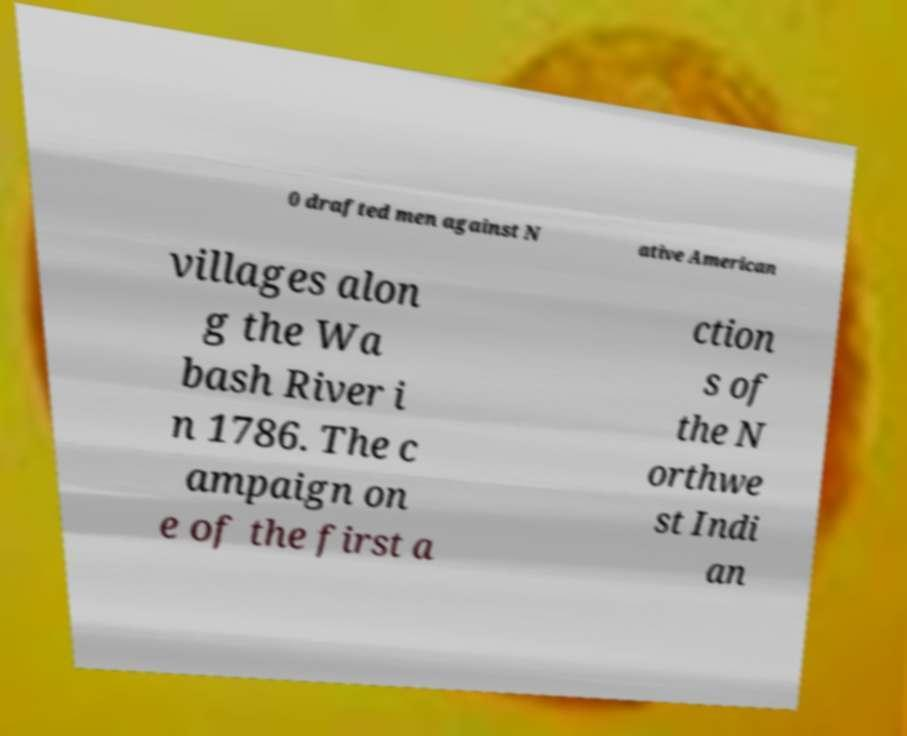Can you accurately transcribe the text from the provided image for me? 0 drafted men against N ative American villages alon g the Wa bash River i n 1786. The c ampaign on e of the first a ction s of the N orthwe st Indi an 